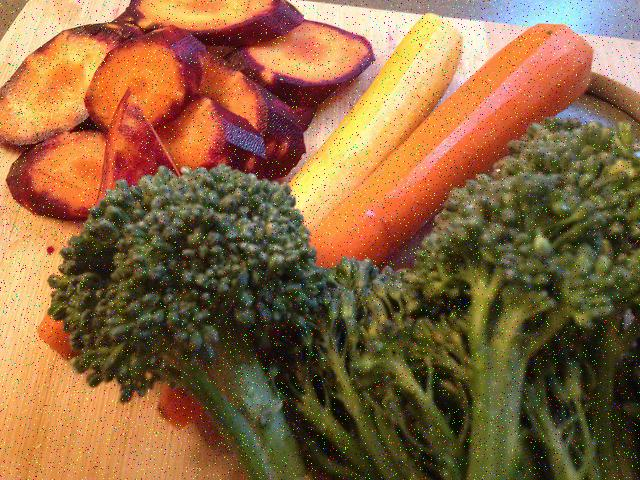Is the lighting in the image sufficient? The photo's lighting appears to be adequate, ensuring that the details of the sliced vegetables and the texture of their surfaces are visible and clear, which gives us an appetizing view of the wholesome food. 